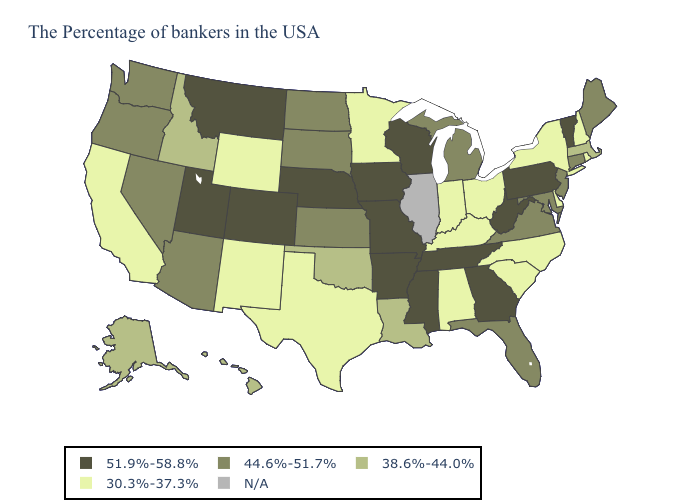Name the states that have a value in the range N/A?
Write a very short answer. Illinois. Name the states that have a value in the range 38.6%-44.0%?
Answer briefly. Massachusetts, Louisiana, Oklahoma, Idaho, Alaska, Hawaii. What is the highest value in the West ?
Short answer required. 51.9%-58.8%. What is the value of Nevada?
Answer briefly. 44.6%-51.7%. What is the lowest value in states that border Arizona?
Keep it brief. 30.3%-37.3%. Name the states that have a value in the range 38.6%-44.0%?
Concise answer only. Massachusetts, Louisiana, Oklahoma, Idaho, Alaska, Hawaii. Is the legend a continuous bar?
Be succinct. No. What is the value of Kansas?
Short answer required. 44.6%-51.7%. What is the value of North Carolina?
Quick response, please. 30.3%-37.3%. Among the states that border California , which have the lowest value?
Answer briefly. Arizona, Nevada, Oregon. Does the first symbol in the legend represent the smallest category?
Write a very short answer. No. Name the states that have a value in the range 30.3%-37.3%?
Write a very short answer. Rhode Island, New Hampshire, New York, Delaware, North Carolina, South Carolina, Ohio, Kentucky, Indiana, Alabama, Minnesota, Texas, Wyoming, New Mexico, California. What is the lowest value in the USA?
Write a very short answer. 30.3%-37.3%. Name the states that have a value in the range 51.9%-58.8%?
Keep it brief. Vermont, Pennsylvania, West Virginia, Georgia, Tennessee, Wisconsin, Mississippi, Missouri, Arkansas, Iowa, Nebraska, Colorado, Utah, Montana. What is the lowest value in states that border West Virginia?
Write a very short answer. 30.3%-37.3%. 